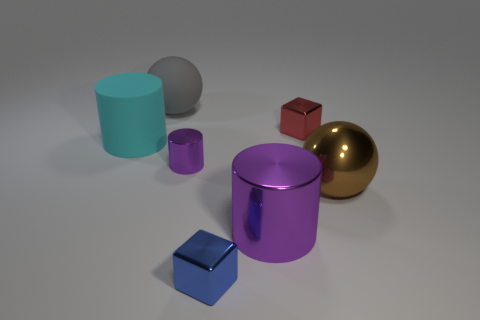There is a thing behind the red thing; what is its material?
Your answer should be compact. Rubber. Are there any other metallic cylinders of the same color as the tiny metal cylinder?
Give a very brief answer. Yes. There is a matte ball that is the same size as the metallic ball; what is its color?
Provide a short and direct response. Gray. What number of large objects are brown metallic balls or cyan cylinders?
Make the answer very short. 2. Are there the same number of large metallic cylinders to the left of the large purple metal cylinder and large brown shiny spheres behind the small red block?
Give a very brief answer. Yes. What number of green metallic balls have the same size as the red metal cube?
Ensure brevity in your answer.  0. What number of yellow objects are either metallic cubes or spheres?
Keep it short and to the point. 0. Is the number of brown metallic things to the right of the large gray ball the same as the number of brown shiny cylinders?
Provide a succinct answer. No. There is a sphere that is in front of the big cyan matte thing; how big is it?
Provide a short and direct response. Large. What number of brown objects have the same shape as the gray thing?
Give a very brief answer. 1. 